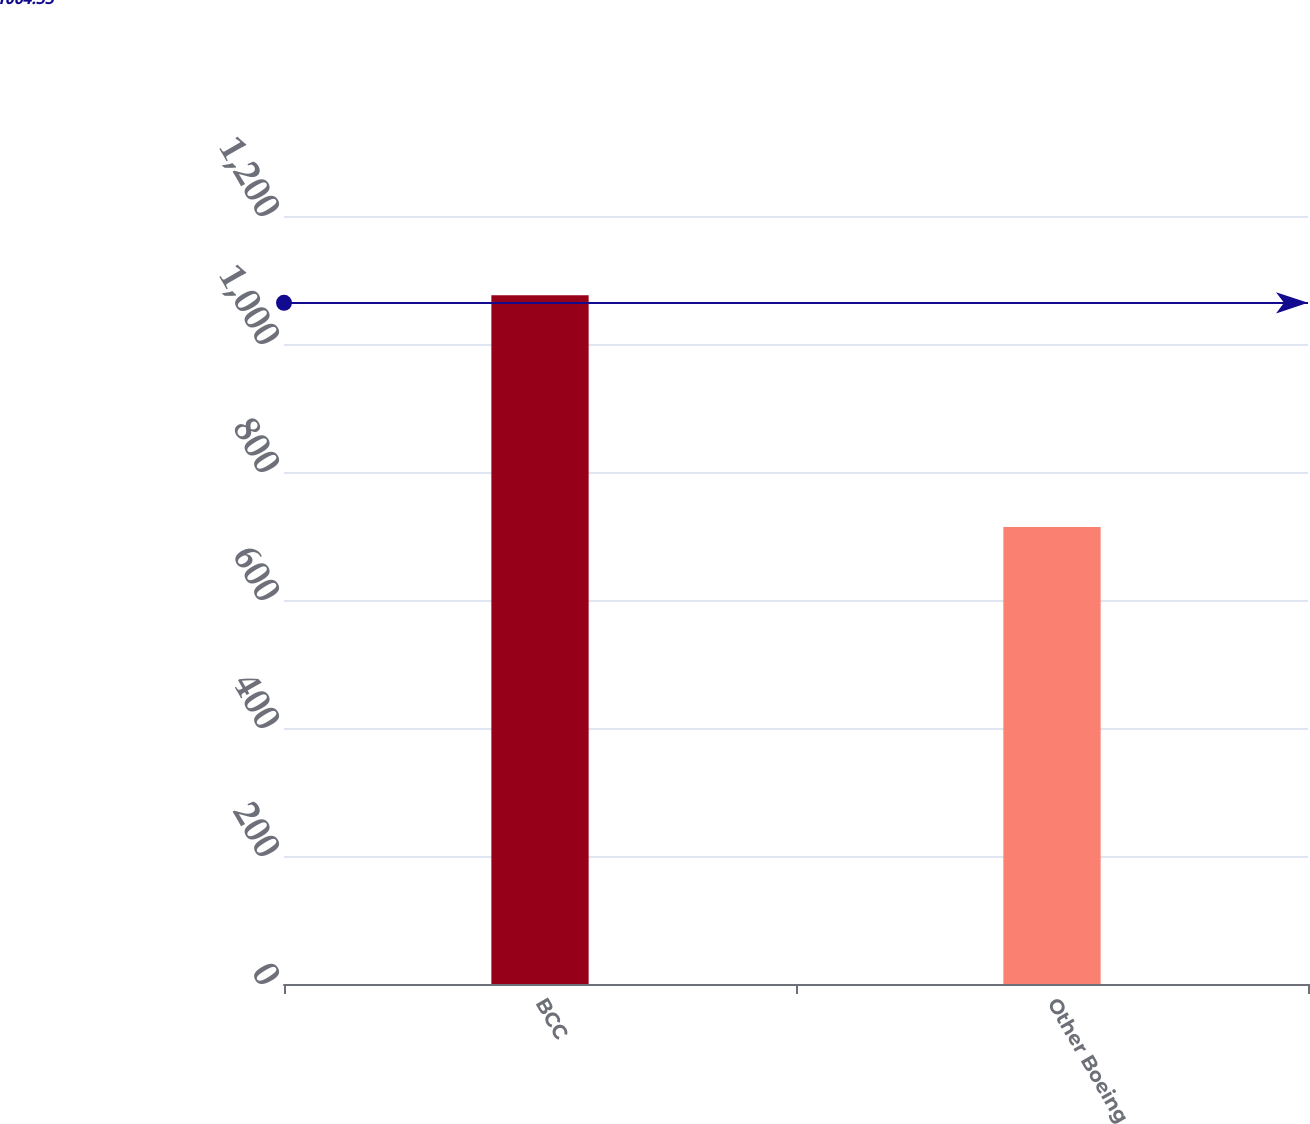Convert chart. <chart><loc_0><loc_0><loc_500><loc_500><bar_chart><fcel>BCC<fcel>Other Boeing<nl><fcel>1076<fcel>714<nl></chart> 